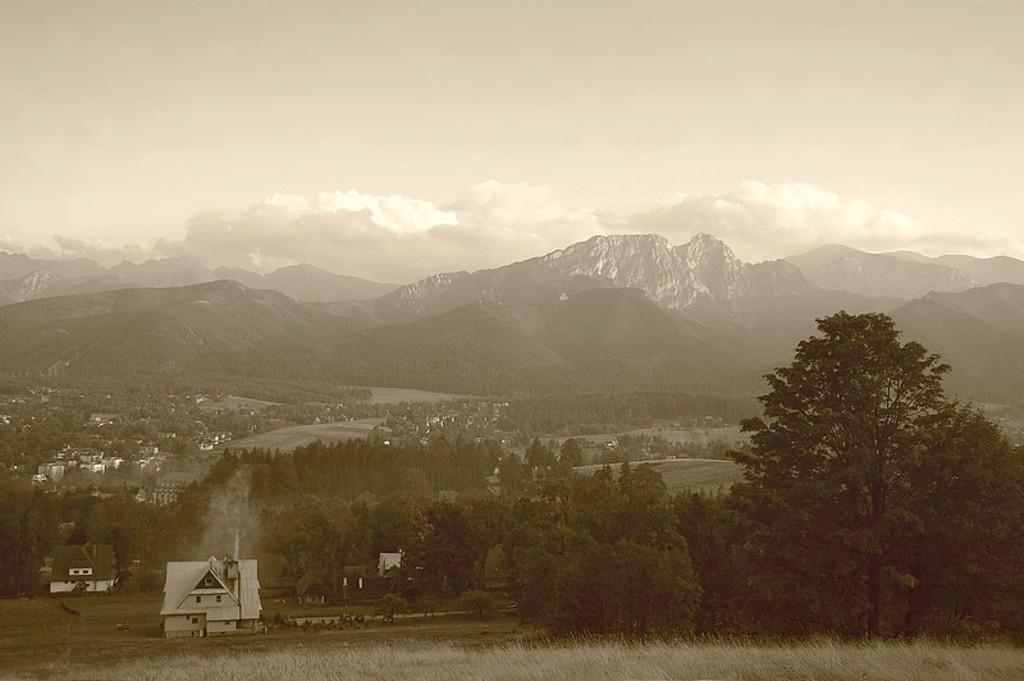What type of structures can be seen in the image? There are houses in the image. What type of vegetation is present in the image? There is grass and trees in the image. What natural feature is visible in the image? There is a mountain in the image. What is visible in the background of the image? The sky is visible in the background of the image. What can be seen in the sky? There are clouds in the sky. How many actors are present in the image? There are no actors present in the image; it features houses, grass, trees, a mountain, and a sky with clouds. What day of the week is depicted in the image? The image does not depict a specific day of the week; it is a general landscape scene. 